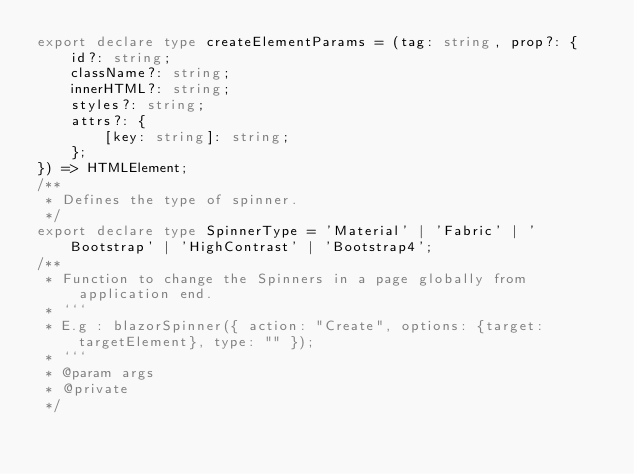<code> <loc_0><loc_0><loc_500><loc_500><_TypeScript_>export declare type createElementParams = (tag: string, prop?: {
    id?: string;
    className?: string;
    innerHTML?: string;
    styles?: string;
    attrs?: {
        [key: string]: string;
    };
}) => HTMLElement;
/**
 * Defines the type of spinner.
 */
export declare type SpinnerType = 'Material' | 'Fabric' | 'Bootstrap' | 'HighContrast' | 'Bootstrap4';
/**
 * Function to change the Spinners in a page globally from application end.
 * ```
 * E.g : blazorSpinner({ action: "Create", options: {target: targetElement}, type: "" });
 * ```
 * @param args
 * @private
 */</code> 